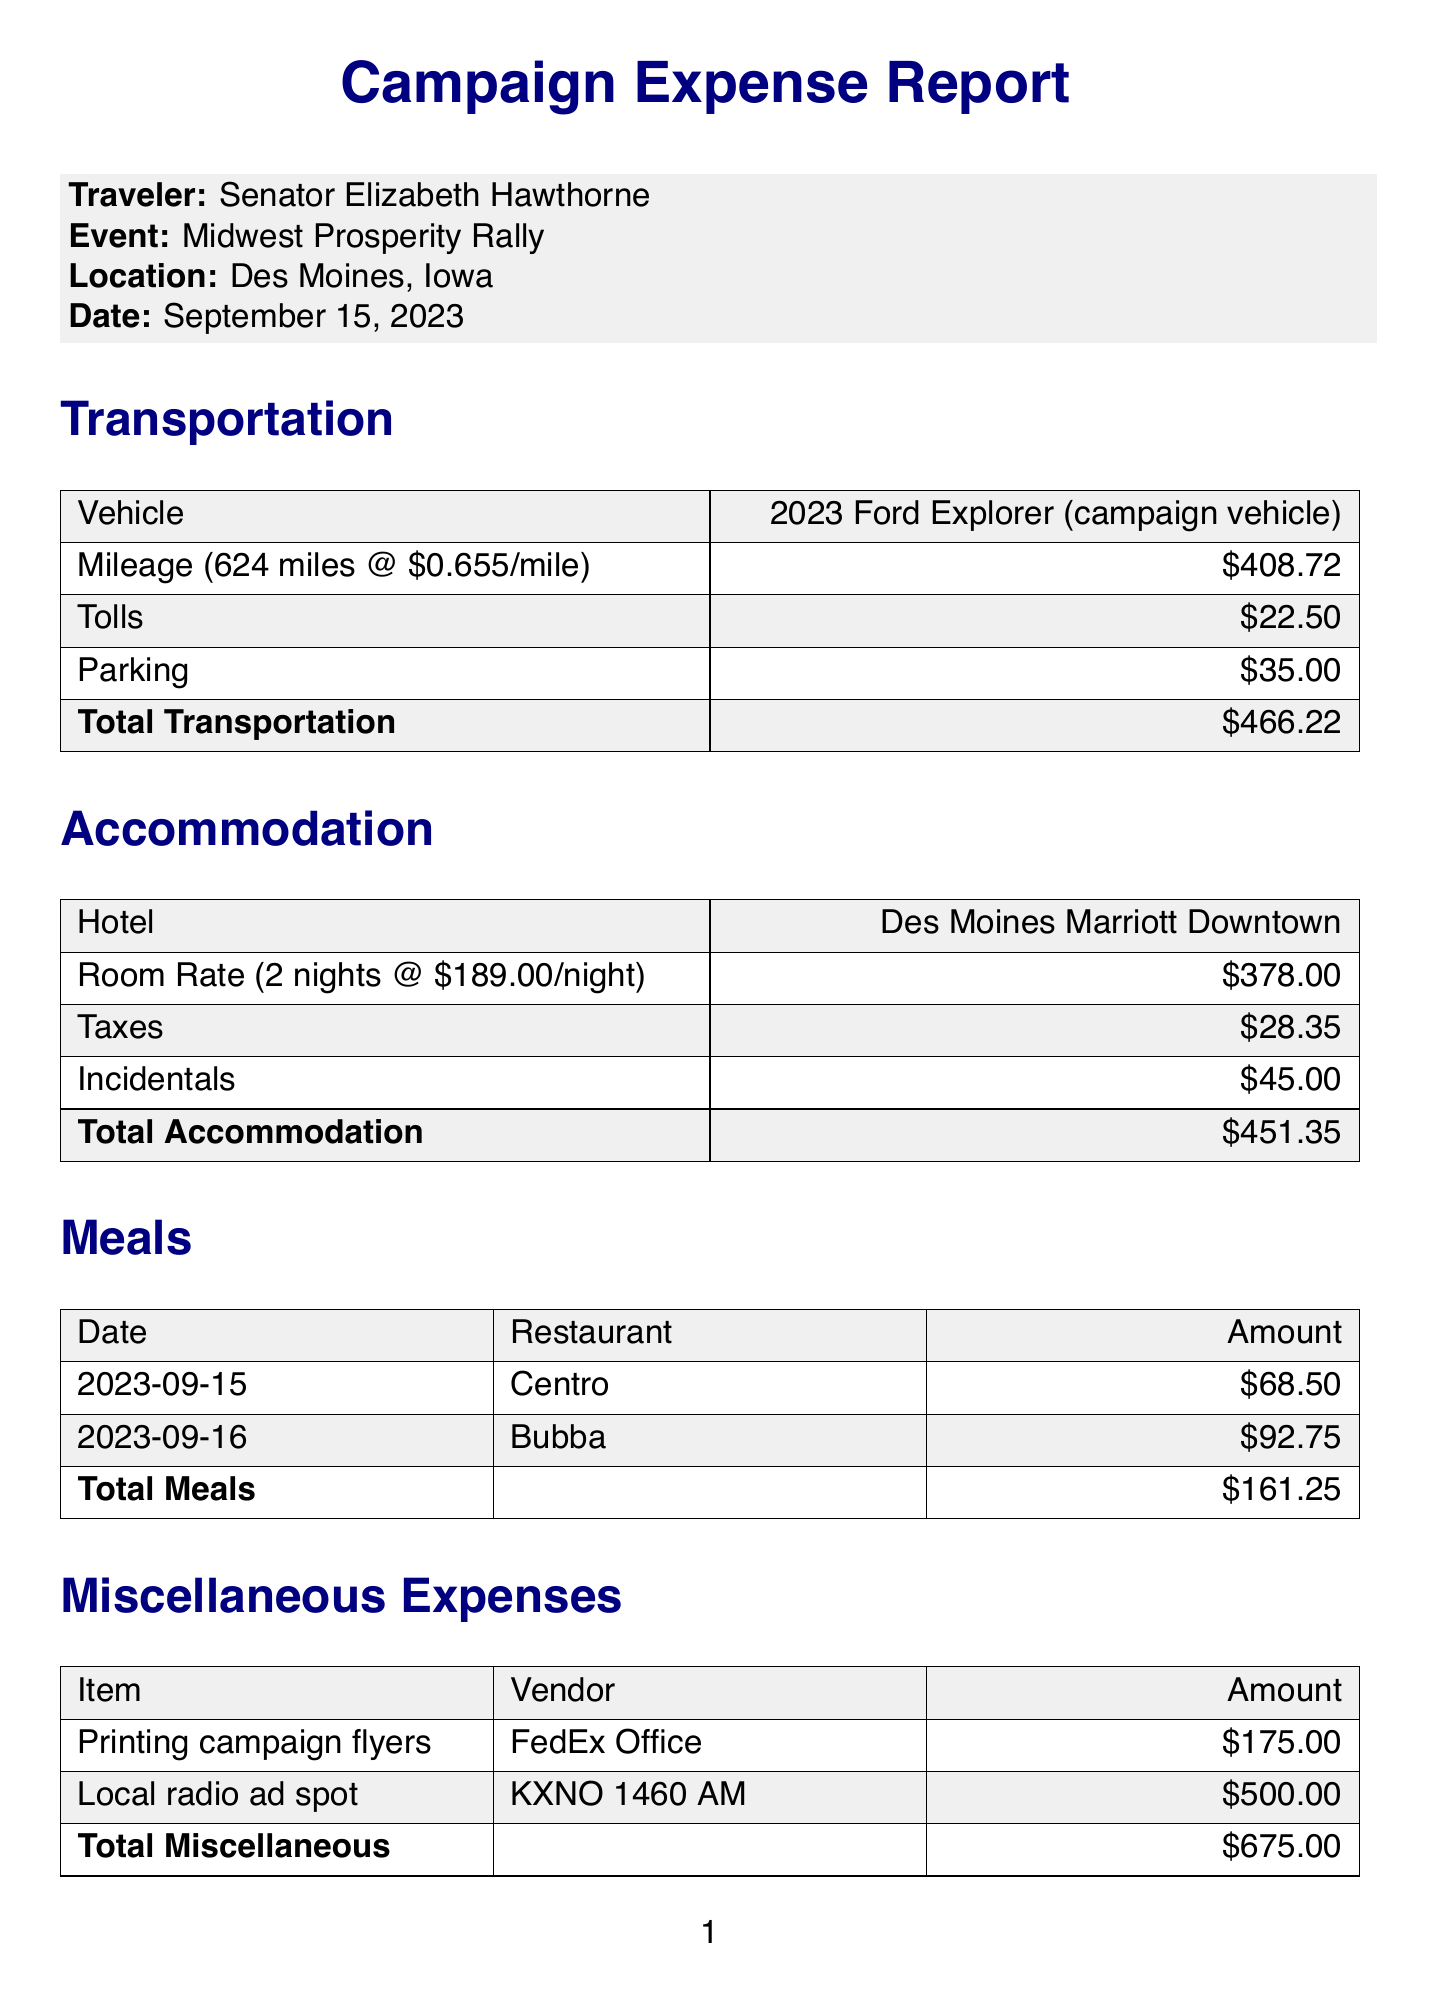What is the location of the rally? The location of the rally is mentioned as Des Moines, Iowa in the document.
Answer: Des Moines, Iowa What was the total mileage reported? The document specifies the total mileage traveled to the event as 624 miles.
Answer: 624 Who were the attendees for the meal at Centro? The attendees for the meal at Centro are listed, which includes Senator Hawthorne, the Campaign Manager, and the Local Organizer.
Answer: Senator Hawthorne, Campaign Manager, Local Organizer What is the total amount for meals? The total for meals is calculated from the individual meal expenses detailed in the document, which sums to $161.25.
Answer: $161.25 How much was spent on miscellaneous expenses? The document indicates the total for miscellaneous expenses as $675.00, including specific items and their costs.
Answer: $675.00 What hotel was used for accommodation? The document names the hotel where accommodation took place as the Des Moines Marriott Downtown.
Answer: Des Moines Marriott Downtown What is the rate for the hotel per night? The hotel rate per night is provided as $189.00 in the accommodation section.
Answer: $189.00 What is the total campaign expense amount? The total campaign expenses are summarized at the end of the document, and it is stated as $1,753.82.
Answer: $1,753.82 What notable endorsement was secured during the event? The document mentions that an endorsement was secured from the Iowa Farmers Union during the rally.
Answer: Iowa Farmers Union 